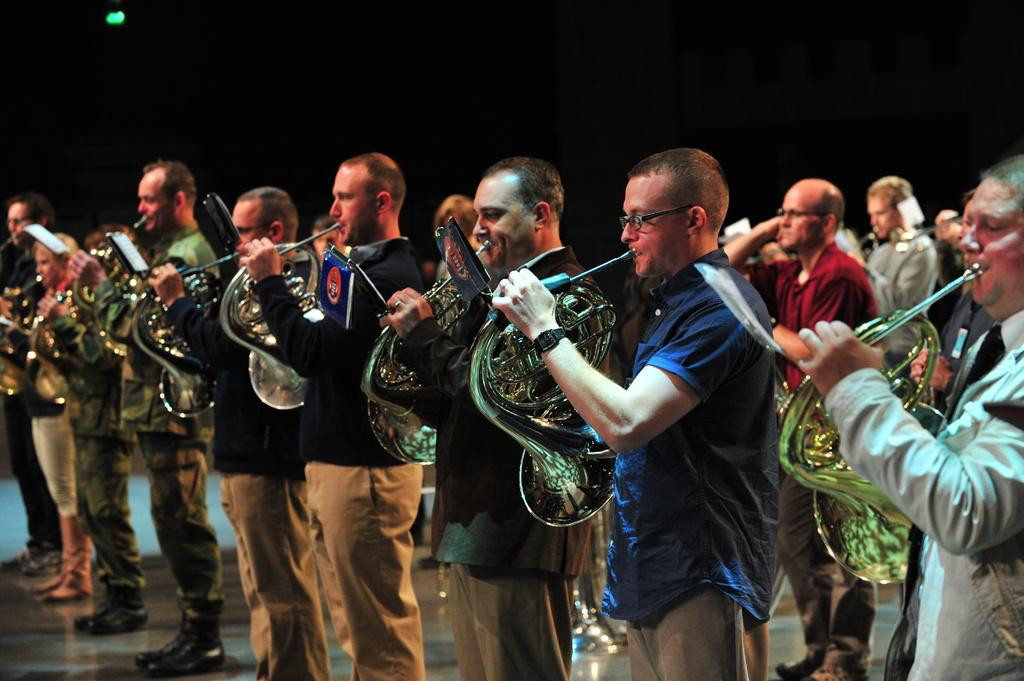What is the main subject of the image? The main subject of the image is a group of people. What are the people in the image doing? The people are standing and playing musical instruments. Are there any other people visible in the image? Yes, there are other persons standing in the background of the image. How would you describe the lighting in the image? The background of the image is dark. What type of produce can be seen growing in the image? There is no produce visible in the image; it features a group of people playing musical instruments. Can you describe the taste of the fowl in the image? There is no fowl present in the image, so it is not possible to describe its taste. 